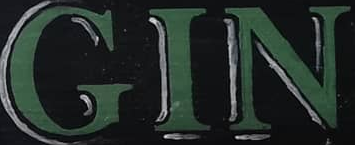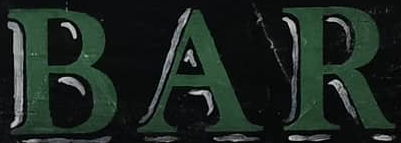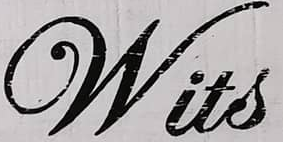Identify the words shown in these images in order, separated by a semicolon. GIN; BAR; Wits 